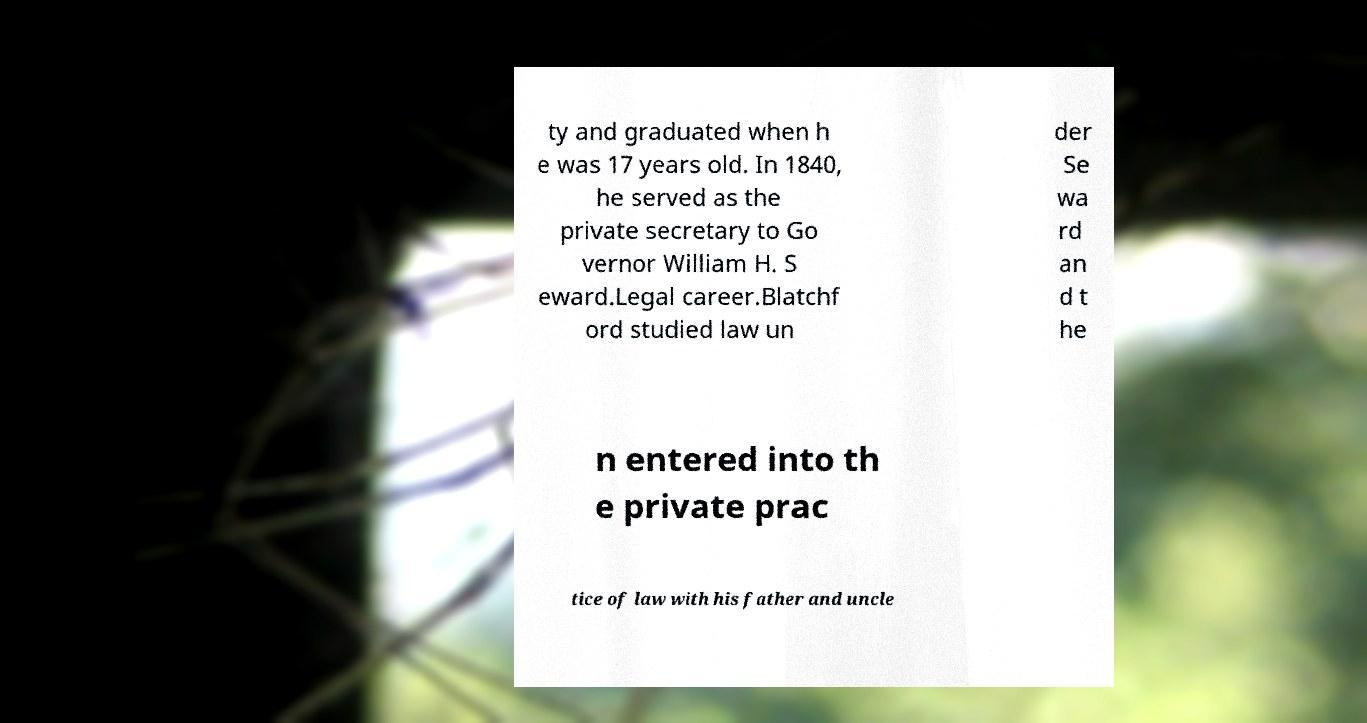Could you assist in decoding the text presented in this image and type it out clearly? ty and graduated when h e was 17 years old. In 1840, he served as the private secretary to Go vernor William H. S eward.Legal career.Blatchf ord studied law un der Se wa rd an d t he n entered into th e private prac tice of law with his father and uncle 